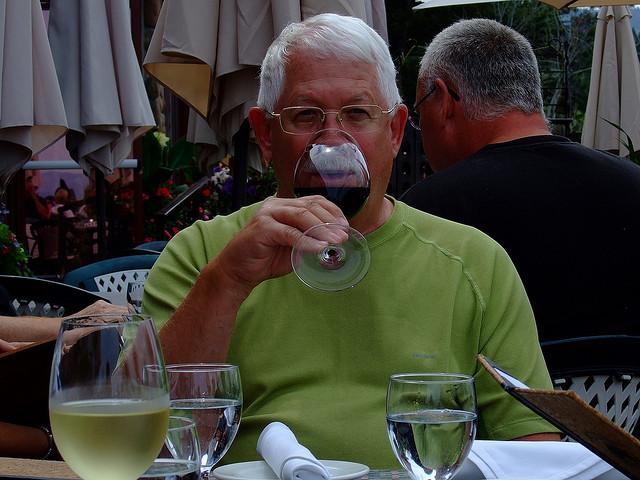How many shirts are black?
Write a very short answer. 1. How many glasses are in the photo?
Concise answer only. 4. What color is the man's wine?
Give a very brief answer. Red. Is the man a wine judge?
Give a very brief answer. No. Is the wine good?
Be succinct. Yes. What is the man drinking?
Keep it brief. Wine. 